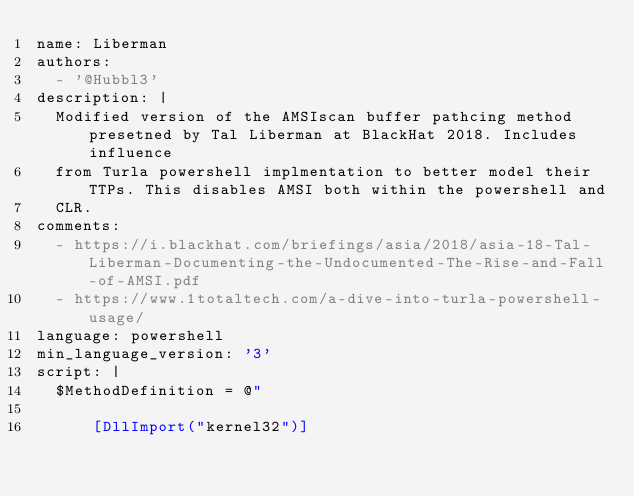<code> <loc_0><loc_0><loc_500><loc_500><_YAML_>name: Liberman
authors:
  - '@Hubbl3'
description: |
  Modified version of the AMSIscan buffer pathcing method presetned by Tal Liberman at BlackHat 2018. Includes influence
  from Turla powershell implmentation to better model their TTPs. This disables AMSI both within the powershell and
  CLR.
comments:
  - https://i.blackhat.com/briefings/asia/2018/asia-18-Tal-Liberman-Documenting-the-Undocumented-The-Rise-and-Fall-of-AMSI.pdf
  - https://www.1totaltech.com/a-dive-into-turla-powershell-usage/
language: powershell
min_language_version: '3'
script: |
  $MethodDefinition = @"

      [DllImport("kernel32")]</code> 